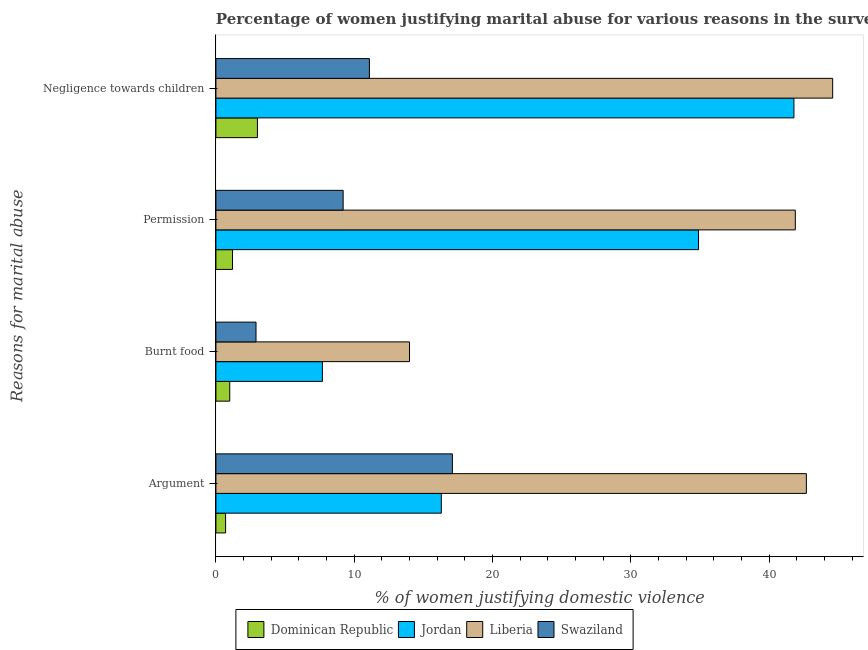How many different coloured bars are there?
Your response must be concise. 4. Are the number of bars per tick equal to the number of legend labels?
Make the answer very short. Yes. Are the number of bars on each tick of the Y-axis equal?
Your answer should be compact. Yes. What is the label of the 1st group of bars from the top?
Give a very brief answer. Negligence towards children. What is the percentage of women justifying abuse for burning food in Swaziland?
Give a very brief answer. 2.9. Across all countries, what is the maximum percentage of women justifying abuse in the case of an argument?
Your answer should be very brief. 42.7. In which country was the percentage of women justifying abuse for going without permission maximum?
Your response must be concise. Liberia. In which country was the percentage of women justifying abuse for going without permission minimum?
Ensure brevity in your answer.  Dominican Republic. What is the total percentage of women justifying abuse for showing negligence towards children in the graph?
Offer a terse response. 100.5. What is the difference between the percentage of women justifying abuse in the case of an argument in Jordan and that in Liberia?
Provide a succinct answer. -26.4. What is the difference between the percentage of women justifying abuse in the case of an argument in Jordan and the percentage of women justifying abuse for burning food in Liberia?
Offer a very short reply. 2.3. What is the average percentage of women justifying abuse for showing negligence towards children per country?
Your answer should be very brief. 25.12. What is the difference between the percentage of women justifying abuse in the case of an argument and percentage of women justifying abuse for going without permission in Swaziland?
Your response must be concise. 7.9. In how many countries, is the percentage of women justifying abuse for showing negligence towards children greater than 32 %?
Your response must be concise. 2. What is the ratio of the percentage of women justifying abuse in the case of an argument in Jordan to that in Swaziland?
Provide a short and direct response. 0.95. Is the difference between the percentage of women justifying abuse in the case of an argument in Dominican Republic and Swaziland greater than the difference between the percentage of women justifying abuse for burning food in Dominican Republic and Swaziland?
Offer a very short reply. No. What is the difference between the highest and the second highest percentage of women justifying abuse for showing negligence towards children?
Keep it short and to the point. 2.8. What is the difference between the highest and the lowest percentage of women justifying abuse for burning food?
Keep it short and to the point. 13. Is it the case that in every country, the sum of the percentage of women justifying abuse for going without permission and percentage of women justifying abuse in the case of an argument is greater than the sum of percentage of women justifying abuse for burning food and percentage of women justifying abuse for showing negligence towards children?
Offer a very short reply. No. What does the 4th bar from the top in Burnt food represents?
Your answer should be compact. Dominican Republic. What does the 3rd bar from the bottom in Negligence towards children represents?
Your answer should be very brief. Liberia. Is it the case that in every country, the sum of the percentage of women justifying abuse in the case of an argument and percentage of women justifying abuse for burning food is greater than the percentage of women justifying abuse for going without permission?
Provide a succinct answer. No. How many bars are there?
Ensure brevity in your answer.  16. Are all the bars in the graph horizontal?
Keep it short and to the point. Yes. Does the graph contain any zero values?
Your answer should be very brief. No. Where does the legend appear in the graph?
Ensure brevity in your answer.  Bottom center. What is the title of the graph?
Offer a terse response. Percentage of women justifying marital abuse for various reasons in the survey of 2007. Does "Virgin Islands" appear as one of the legend labels in the graph?
Offer a very short reply. No. What is the label or title of the X-axis?
Provide a short and direct response. % of women justifying domestic violence. What is the label or title of the Y-axis?
Provide a succinct answer. Reasons for marital abuse. What is the % of women justifying domestic violence in Jordan in Argument?
Provide a short and direct response. 16.3. What is the % of women justifying domestic violence of Liberia in Argument?
Offer a terse response. 42.7. What is the % of women justifying domestic violence in Liberia in Burnt food?
Your response must be concise. 14. What is the % of women justifying domestic violence in Swaziland in Burnt food?
Give a very brief answer. 2.9. What is the % of women justifying domestic violence in Jordan in Permission?
Make the answer very short. 34.9. What is the % of women justifying domestic violence of Liberia in Permission?
Make the answer very short. 41.9. What is the % of women justifying domestic violence of Jordan in Negligence towards children?
Offer a terse response. 41.8. What is the % of women justifying domestic violence in Liberia in Negligence towards children?
Make the answer very short. 44.6. Across all Reasons for marital abuse, what is the maximum % of women justifying domestic violence of Jordan?
Offer a very short reply. 41.8. Across all Reasons for marital abuse, what is the maximum % of women justifying domestic violence of Liberia?
Make the answer very short. 44.6. Across all Reasons for marital abuse, what is the maximum % of women justifying domestic violence in Swaziland?
Ensure brevity in your answer.  17.1. What is the total % of women justifying domestic violence of Jordan in the graph?
Offer a terse response. 100.7. What is the total % of women justifying domestic violence in Liberia in the graph?
Give a very brief answer. 143.2. What is the total % of women justifying domestic violence in Swaziland in the graph?
Give a very brief answer. 40.3. What is the difference between the % of women justifying domestic violence of Jordan in Argument and that in Burnt food?
Your response must be concise. 8.6. What is the difference between the % of women justifying domestic violence of Liberia in Argument and that in Burnt food?
Keep it short and to the point. 28.7. What is the difference between the % of women justifying domestic violence in Swaziland in Argument and that in Burnt food?
Provide a succinct answer. 14.2. What is the difference between the % of women justifying domestic violence of Jordan in Argument and that in Permission?
Offer a very short reply. -18.6. What is the difference between the % of women justifying domestic violence of Liberia in Argument and that in Permission?
Provide a succinct answer. 0.8. What is the difference between the % of women justifying domestic violence in Jordan in Argument and that in Negligence towards children?
Your answer should be compact. -25.5. What is the difference between the % of women justifying domestic violence in Liberia in Argument and that in Negligence towards children?
Give a very brief answer. -1.9. What is the difference between the % of women justifying domestic violence in Dominican Republic in Burnt food and that in Permission?
Your answer should be very brief. -0.2. What is the difference between the % of women justifying domestic violence in Jordan in Burnt food and that in Permission?
Your answer should be very brief. -27.2. What is the difference between the % of women justifying domestic violence in Liberia in Burnt food and that in Permission?
Keep it short and to the point. -27.9. What is the difference between the % of women justifying domestic violence of Jordan in Burnt food and that in Negligence towards children?
Ensure brevity in your answer.  -34.1. What is the difference between the % of women justifying domestic violence in Liberia in Burnt food and that in Negligence towards children?
Your answer should be very brief. -30.6. What is the difference between the % of women justifying domestic violence in Swaziland in Burnt food and that in Negligence towards children?
Your answer should be compact. -8.2. What is the difference between the % of women justifying domestic violence of Dominican Republic in Permission and that in Negligence towards children?
Provide a succinct answer. -1.8. What is the difference between the % of women justifying domestic violence in Liberia in Permission and that in Negligence towards children?
Offer a very short reply. -2.7. What is the difference between the % of women justifying domestic violence in Swaziland in Permission and that in Negligence towards children?
Ensure brevity in your answer.  -1.9. What is the difference between the % of women justifying domestic violence of Dominican Republic in Argument and the % of women justifying domestic violence of Jordan in Burnt food?
Your answer should be very brief. -7. What is the difference between the % of women justifying domestic violence of Jordan in Argument and the % of women justifying domestic violence of Swaziland in Burnt food?
Your answer should be very brief. 13.4. What is the difference between the % of women justifying domestic violence in Liberia in Argument and the % of women justifying domestic violence in Swaziland in Burnt food?
Your answer should be compact. 39.8. What is the difference between the % of women justifying domestic violence of Dominican Republic in Argument and the % of women justifying domestic violence of Jordan in Permission?
Provide a short and direct response. -34.2. What is the difference between the % of women justifying domestic violence in Dominican Republic in Argument and the % of women justifying domestic violence in Liberia in Permission?
Your answer should be compact. -41.2. What is the difference between the % of women justifying domestic violence in Jordan in Argument and the % of women justifying domestic violence in Liberia in Permission?
Your answer should be very brief. -25.6. What is the difference between the % of women justifying domestic violence in Liberia in Argument and the % of women justifying domestic violence in Swaziland in Permission?
Make the answer very short. 33.5. What is the difference between the % of women justifying domestic violence of Dominican Republic in Argument and the % of women justifying domestic violence of Jordan in Negligence towards children?
Keep it short and to the point. -41.1. What is the difference between the % of women justifying domestic violence in Dominican Republic in Argument and the % of women justifying domestic violence in Liberia in Negligence towards children?
Your answer should be very brief. -43.9. What is the difference between the % of women justifying domestic violence of Jordan in Argument and the % of women justifying domestic violence of Liberia in Negligence towards children?
Ensure brevity in your answer.  -28.3. What is the difference between the % of women justifying domestic violence of Jordan in Argument and the % of women justifying domestic violence of Swaziland in Negligence towards children?
Provide a short and direct response. 5.2. What is the difference between the % of women justifying domestic violence in Liberia in Argument and the % of women justifying domestic violence in Swaziland in Negligence towards children?
Keep it short and to the point. 31.6. What is the difference between the % of women justifying domestic violence in Dominican Republic in Burnt food and the % of women justifying domestic violence in Jordan in Permission?
Give a very brief answer. -33.9. What is the difference between the % of women justifying domestic violence of Dominican Republic in Burnt food and the % of women justifying domestic violence of Liberia in Permission?
Your answer should be very brief. -40.9. What is the difference between the % of women justifying domestic violence in Jordan in Burnt food and the % of women justifying domestic violence in Liberia in Permission?
Provide a short and direct response. -34.2. What is the difference between the % of women justifying domestic violence in Dominican Republic in Burnt food and the % of women justifying domestic violence in Jordan in Negligence towards children?
Your response must be concise. -40.8. What is the difference between the % of women justifying domestic violence of Dominican Republic in Burnt food and the % of women justifying domestic violence of Liberia in Negligence towards children?
Make the answer very short. -43.6. What is the difference between the % of women justifying domestic violence of Jordan in Burnt food and the % of women justifying domestic violence of Liberia in Negligence towards children?
Keep it short and to the point. -36.9. What is the difference between the % of women justifying domestic violence in Dominican Republic in Permission and the % of women justifying domestic violence in Jordan in Negligence towards children?
Keep it short and to the point. -40.6. What is the difference between the % of women justifying domestic violence in Dominican Republic in Permission and the % of women justifying domestic violence in Liberia in Negligence towards children?
Offer a very short reply. -43.4. What is the difference between the % of women justifying domestic violence of Dominican Republic in Permission and the % of women justifying domestic violence of Swaziland in Negligence towards children?
Your response must be concise. -9.9. What is the difference between the % of women justifying domestic violence in Jordan in Permission and the % of women justifying domestic violence in Swaziland in Negligence towards children?
Provide a succinct answer. 23.8. What is the difference between the % of women justifying domestic violence of Liberia in Permission and the % of women justifying domestic violence of Swaziland in Negligence towards children?
Offer a very short reply. 30.8. What is the average % of women justifying domestic violence of Dominican Republic per Reasons for marital abuse?
Your answer should be very brief. 1.48. What is the average % of women justifying domestic violence in Jordan per Reasons for marital abuse?
Give a very brief answer. 25.18. What is the average % of women justifying domestic violence in Liberia per Reasons for marital abuse?
Your answer should be compact. 35.8. What is the average % of women justifying domestic violence in Swaziland per Reasons for marital abuse?
Ensure brevity in your answer.  10.07. What is the difference between the % of women justifying domestic violence of Dominican Republic and % of women justifying domestic violence of Jordan in Argument?
Provide a short and direct response. -15.6. What is the difference between the % of women justifying domestic violence in Dominican Republic and % of women justifying domestic violence in Liberia in Argument?
Your answer should be compact. -42. What is the difference between the % of women justifying domestic violence of Dominican Republic and % of women justifying domestic violence of Swaziland in Argument?
Offer a very short reply. -16.4. What is the difference between the % of women justifying domestic violence in Jordan and % of women justifying domestic violence in Liberia in Argument?
Your response must be concise. -26.4. What is the difference between the % of women justifying domestic violence in Liberia and % of women justifying domestic violence in Swaziland in Argument?
Provide a succinct answer. 25.6. What is the difference between the % of women justifying domestic violence in Dominican Republic and % of women justifying domestic violence in Jordan in Burnt food?
Offer a very short reply. -6.7. What is the difference between the % of women justifying domestic violence in Dominican Republic and % of women justifying domestic violence in Swaziland in Burnt food?
Your answer should be very brief. -1.9. What is the difference between the % of women justifying domestic violence in Jordan and % of women justifying domestic violence in Swaziland in Burnt food?
Give a very brief answer. 4.8. What is the difference between the % of women justifying domestic violence in Liberia and % of women justifying domestic violence in Swaziland in Burnt food?
Make the answer very short. 11.1. What is the difference between the % of women justifying domestic violence in Dominican Republic and % of women justifying domestic violence in Jordan in Permission?
Give a very brief answer. -33.7. What is the difference between the % of women justifying domestic violence in Dominican Republic and % of women justifying domestic violence in Liberia in Permission?
Provide a short and direct response. -40.7. What is the difference between the % of women justifying domestic violence in Dominican Republic and % of women justifying domestic violence in Swaziland in Permission?
Give a very brief answer. -8. What is the difference between the % of women justifying domestic violence in Jordan and % of women justifying domestic violence in Swaziland in Permission?
Keep it short and to the point. 25.7. What is the difference between the % of women justifying domestic violence in Liberia and % of women justifying domestic violence in Swaziland in Permission?
Your answer should be very brief. 32.7. What is the difference between the % of women justifying domestic violence in Dominican Republic and % of women justifying domestic violence in Jordan in Negligence towards children?
Keep it short and to the point. -38.8. What is the difference between the % of women justifying domestic violence in Dominican Republic and % of women justifying domestic violence in Liberia in Negligence towards children?
Keep it short and to the point. -41.6. What is the difference between the % of women justifying domestic violence in Dominican Republic and % of women justifying domestic violence in Swaziland in Negligence towards children?
Ensure brevity in your answer.  -8.1. What is the difference between the % of women justifying domestic violence of Jordan and % of women justifying domestic violence of Liberia in Negligence towards children?
Your answer should be compact. -2.8. What is the difference between the % of women justifying domestic violence in Jordan and % of women justifying domestic violence in Swaziland in Negligence towards children?
Offer a very short reply. 30.7. What is the difference between the % of women justifying domestic violence in Liberia and % of women justifying domestic violence in Swaziland in Negligence towards children?
Your answer should be compact. 33.5. What is the ratio of the % of women justifying domestic violence in Dominican Republic in Argument to that in Burnt food?
Provide a short and direct response. 0.7. What is the ratio of the % of women justifying domestic violence in Jordan in Argument to that in Burnt food?
Your answer should be very brief. 2.12. What is the ratio of the % of women justifying domestic violence of Liberia in Argument to that in Burnt food?
Give a very brief answer. 3.05. What is the ratio of the % of women justifying domestic violence in Swaziland in Argument to that in Burnt food?
Provide a short and direct response. 5.9. What is the ratio of the % of women justifying domestic violence of Dominican Republic in Argument to that in Permission?
Offer a very short reply. 0.58. What is the ratio of the % of women justifying domestic violence in Jordan in Argument to that in Permission?
Your answer should be very brief. 0.47. What is the ratio of the % of women justifying domestic violence in Liberia in Argument to that in Permission?
Keep it short and to the point. 1.02. What is the ratio of the % of women justifying domestic violence of Swaziland in Argument to that in Permission?
Offer a terse response. 1.86. What is the ratio of the % of women justifying domestic violence in Dominican Republic in Argument to that in Negligence towards children?
Offer a terse response. 0.23. What is the ratio of the % of women justifying domestic violence in Jordan in Argument to that in Negligence towards children?
Provide a succinct answer. 0.39. What is the ratio of the % of women justifying domestic violence of Liberia in Argument to that in Negligence towards children?
Your answer should be very brief. 0.96. What is the ratio of the % of women justifying domestic violence of Swaziland in Argument to that in Negligence towards children?
Your response must be concise. 1.54. What is the ratio of the % of women justifying domestic violence in Dominican Republic in Burnt food to that in Permission?
Make the answer very short. 0.83. What is the ratio of the % of women justifying domestic violence in Jordan in Burnt food to that in Permission?
Provide a succinct answer. 0.22. What is the ratio of the % of women justifying domestic violence of Liberia in Burnt food to that in Permission?
Offer a terse response. 0.33. What is the ratio of the % of women justifying domestic violence in Swaziland in Burnt food to that in Permission?
Give a very brief answer. 0.32. What is the ratio of the % of women justifying domestic violence of Dominican Republic in Burnt food to that in Negligence towards children?
Keep it short and to the point. 0.33. What is the ratio of the % of women justifying domestic violence of Jordan in Burnt food to that in Negligence towards children?
Your response must be concise. 0.18. What is the ratio of the % of women justifying domestic violence in Liberia in Burnt food to that in Negligence towards children?
Your answer should be compact. 0.31. What is the ratio of the % of women justifying domestic violence in Swaziland in Burnt food to that in Negligence towards children?
Keep it short and to the point. 0.26. What is the ratio of the % of women justifying domestic violence of Jordan in Permission to that in Negligence towards children?
Provide a succinct answer. 0.83. What is the ratio of the % of women justifying domestic violence of Liberia in Permission to that in Negligence towards children?
Offer a very short reply. 0.94. What is the ratio of the % of women justifying domestic violence of Swaziland in Permission to that in Negligence towards children?
Offer a very short reply. 0.83. What is the difference between the highest and the second highest % of women justifying domestic violence of Dominican Republic?
Offer a terse response. 1.8. What is the difference between the highest and the lowest % of women justifying domestic violence in Dominican Republic?
Your answer should be very brief. 2.3. What is the difference between the highest and the lowest % of women justifying domestic violence of Jordan?
Your answer should be very brief. 34.1. What is the difference between the highest and the lowest % of women justifying domestic violence of Liberia?
Offer a very short reply. 30.6. 